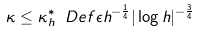<formula> <loc_0><loc_0><loc_500><loc_500>\kappa \leq \kappa ^ { * } _ { h } \ D e f \epsilon h ^ { - \frac { 1 } { 4 } } | \log h | ^ { - \frac { 3 } { 4 } }</formula> 